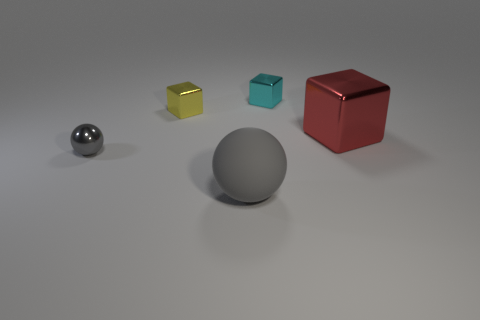There is a tiny block that is behind the block left of the metal thing that is behind the small yellow object; what is its material?
Offer a very short reply. Metal. Is there a gray rubber object of the same shape as the tiny yellow object?
Provide a short and direct response. No. There is a matte thing that is the same size as the red shiny block; what is its shape?
Your answer should be very brief. Sphere. How many objects are both to the right of the small metal sphere and in front of the large shiny cube?
Provide a succinct answer. 1. Is the number of large red shiny things in front of the large gray ball less than the number of small red shiny spheres?
Provide a succinct answer. No. Is there a gray metal object of the same size as the yellow cube?
Keep it short and to the point. Yes. What color is the ball that is made of the same material as the small cyan cube?
Offer a terse response. Gray. How many tiny shiny objects are on the right side of the tiny gray thing that is on the left side of the gray rubber sphere?
Offer a very short reply. 2. There is a object that is both on the left side of the gray rubber object and in front of the yellow shiny object; what is its material?
Your response must be concise. Metal. Does the big thing right of the big gray rubber thing have the same shape as the large rubber thing?
Your answer should be compact. No. 